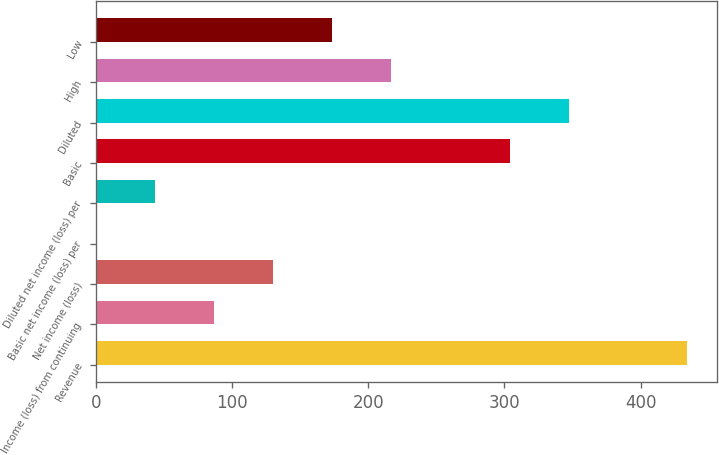<chart> <loc_0><loc_0><loc_500><loc_500><bar_chart><fcel>Revenue<fcel>Income (loss) from continuing<fcel>Net income (loss)<fcel>Basic net income (loss) per<fcel>Diluted net income (loss) per<fcel>Basic<fcel>Diluted<fcel>High<fcel>Low<nl><fcel>434<fcel>86.84<fcel>130.24<fcel>0.05<fcel>43.45<fcel>303.82<fcel>347.21<fcel>217.03<fcel>173.64<nl></chart> 